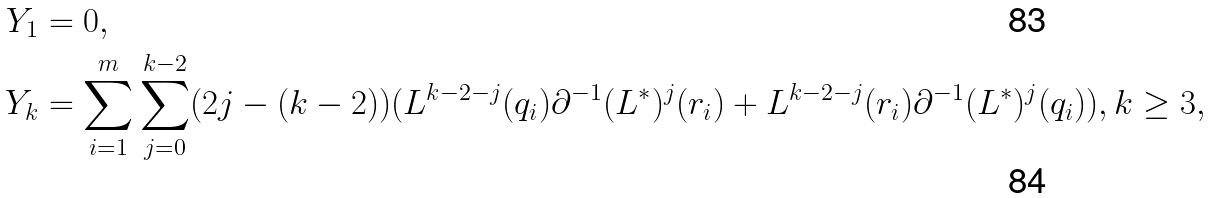Convert formula to latex. <formula><loc_0><loc_0><loc_500><loc_500>Y _ { 1 } & = 0 , \\ Y _ { k } & = \sum _ { i = 1 } ^ { m } \sum _ { j = 0 } ^ { k - 2 } ( 2 j - ( k - 2 ) ) ( L ^ { k - 2 - j } ( q _ { i } ) \partial ^ { - 1 } ( L ^ { * } ) ^ { j } ( r _ { i } ) + L ^ { k - 2 - j } ( r _ { i } ) \partial ^ { - 1 } ( L ^ { * } ) ^ { j } ( q _ { i } ) ) , k \geq 3 ,</formula> 